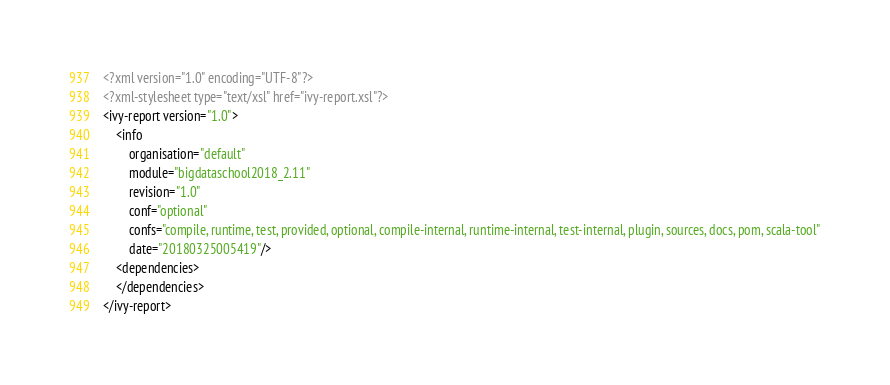Convert code to text. <code><loc_0><loc_0><loc_500><loc_500><_XML_><?xml version="1.0" encoding="UTF-8"?>
<?xml-stylesheet type="text/xsl" href="ivy-report.xsl"?>
<ivy-report version="1.0">
	<info
		organisation="default"
		module="bigdataschool2018_2.11"
		revision="1.0"
		conf="optional"
		confs="compile, runtime, test, provided, optional, compile-internal, runtime-internal, test-internal, plugin, sources, docs, pom, scala-tool"
		date="20180325005419"/>
	<dependencies>
	</dependencies>
</ivy-report>
</code> 